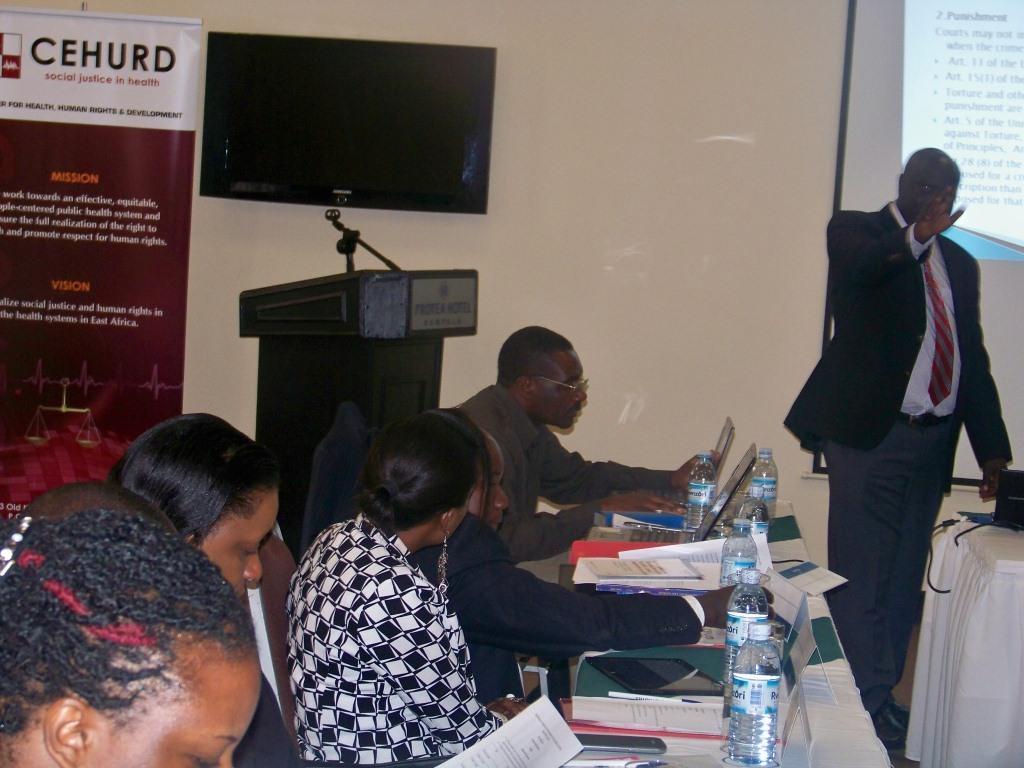How would you summarize this image in a sentence or two? In the foreground of this image, on the left, there are persons sitting on the chairs in front of a table on which there are bottles, papers, books, laptops, mobile and a tab. In the background left, there is a podium, banner and the wall. On the right, there is a man standing in front of a table on which, there is a laptop. In the background, there is a screen on a white board. 